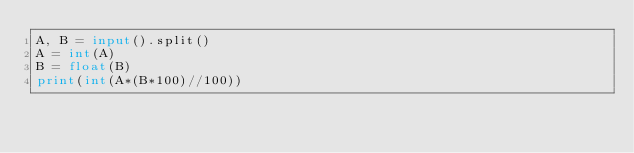Convert code to text. <code><loc_0><loc_0><loc_500><loc_500><_Python_>A, B = input().split()
A = int(A)
B = float(B)
print(int(A*(B*100)//100))
</code> 